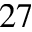<formula> <loc_0><loc_0><loc_500><loc_500>2 7</formula> 